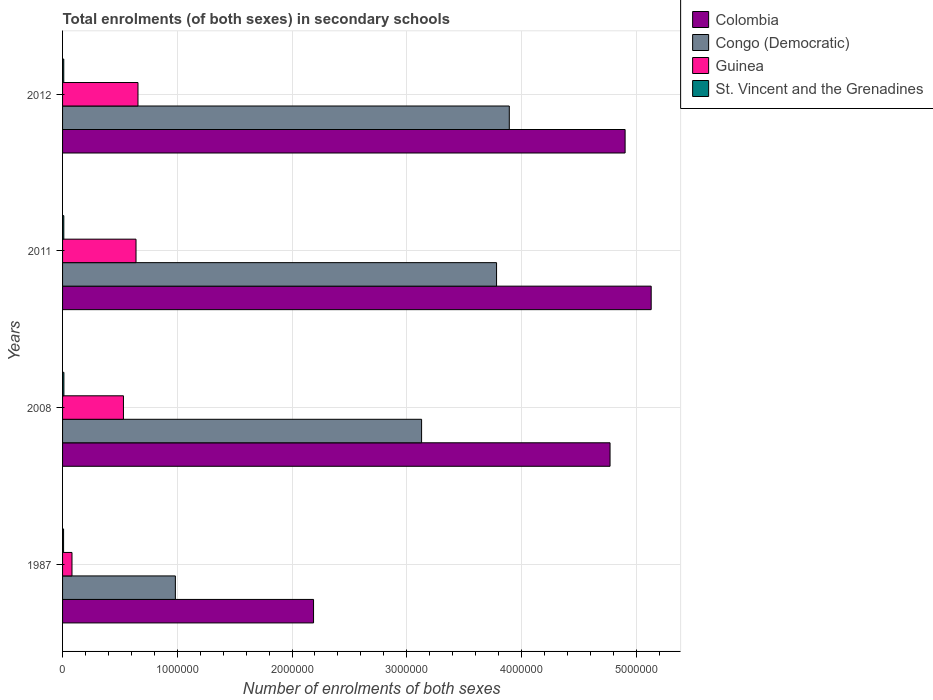How many groups of bars are there?
Provide a short and direct response. 4. Are the number of bars per tick equal to the number of legend labels?
Offer a terse response. Yes. How many bars are there on the 3rd tick from the top?
Your response must be concise. 4. How many bars are there on the 3rd tick from the bottom?
Provide a succinct answer. 4. What is the label of the 1st group of bars from the top?
Provide a short and direct response. 2012. What is the number of enrolments in secondary schools in Guinea in 2011?
Offer a very short reply. 6.40e+05. Across all years, what is the maximum number of enrolments in secondary schools in Congo (Democratic)?
Your answer should be very brief. 3.89e+06. Across all years, what is the minimum number of enrolments in secondary schools in Congo (Democratic)?
Give a very brief answer. 9.83e+05. In which year was the number of enrolments in secondary schools in Guinea maximum?
Provide a succinct answer. 2012. What is the total number of enrolments in secondary schools in Guinea in the graph?
Keep it short and to the point. 1.91e+06. What is the difference between the number of enrolments in secondary schools in St. Vincent and the Grenadines in 2008 and that in 2011?
Your response must be concise. 714. What is the difference between the number of enrolments in secondary schools in St. Vincent and the Grenadines in 1987 and the number of enrolments in secondary schools in Colombia in 2012?
Make the answer very short. -4.89e+06. What is the average number of enrolments in secondary schools in Congo (Democratic) per year?
Your response must be concise. 2.95e+06. In the year 2011, what is the difference between the number of enrolments in secondary schools in Colombia and number of enrolments in secondary schools in St. Vincent and the Grenadines?
Provide a short and direct response. 5.12e+06. What is the ratio of the number of enrolments in secondary schools in Congo (Democratic) in 2011 to that in 2012?
Keep it short and to the point. 0.97. What is the difference between the highest and the second highest number of enrolments in secondary schools in St. Vincent and the Grenadines?
Provide a short and direct response. 714. What is the difference between the highest and the lowest number of enrolments in secondary schools in Colombia?
Offer a terse response. 2.94e+06. Is the sum of the number of enrolments in secondary schools in St. Vincent and the Grenadines in 2011 and 2012 greater than the maximum number of enrolments in secondary schools in Guinea across all years?
Your answer should be compact. No. Is it the case that in every year, the sum of the number of enrolments in secondary schools in Colombia and number of enrolments in secondary schools in Guinea is greater than the sum of number of enrolments in secondary schools in St. Vincent and the Grenadines and number of enrolments in secondary schools in Congo (Democratic)?
Your answer should be compact. Yes. What does the 2nd bar from the top in 2012 represents?
Offer a terse response. Guinea. What does the 3rd bar from the bottom in 2012 represents?
Provide a short and direct response. Guinea. Is it the case that in every year, the sum of the number of enrolments in secondary schools in Congo (Democratic) and number of enrolments in secondary schools in Guinea is greater than the number of enrolments in secondary schools in St. Vincent and the Grenadines?
Your answer should be very brief. Yes. Are all the bars in the graph horizontal?
Give a very brief answer. Yes. How many years are there in the graph?
Make the answer very short. 4. What is the difference between two consecutive major ticks on the X-axis?
Keep it short and to the point. 1.00e+06. Are the values on the major ticks of X-axis written in scientific E-notation?
Offer a very short reply. No. Does the graph contain any zero values?
Your answer should be compact. No. Where does the legend appear in the graph?
Offer a terse response. Top right. How many legend labels are there?
Give a very brief answer. 4. What is the title of the graph?
Your answer should be compact. Total enrolments (of both sexes) in secondary schools. Does "Heavily indebted poor countries" appear as one of the legend labels in the graph?
Your answer should be compact. No. What is the label or title of the X-axis?
Give a very brief answer. Number of enrolments of both sexes. What is the Number of enrolments of both sexes of Colombia in 1987?
Your answer should be compact. 2.19e+06. What is the Number of enrolments of both sexes in Congo (Democratic) in 1987?
Your answer should be very brief. 9.83e+05. What is the Number of enrolments of both sexes in Guinea in 1987?
Provide a short and direct response. 8.21e+04. What is the Number of enrolments of both sexes of St. Vincent and the Grenadines in 1987?
Your answer should be very brief. 8785. What is the Number of enrolments of both sexes of Colombia in 2008?
Your response must be concise. 4.77e+06. What is the Number of enrolments of both sexes in Congo (Democratic) in 2008?
Make the answer very short. 3.13e+06. What is the Number of enrolments of both sexes in Guinea in 2008?
Your answer should be compact. 5.31e+05. What is the Number of enrolments of both sexes in St. Vincent and the Grenadines in 2008?
Provide a succinct answer. 1.16e+04. What is the Number of enrolments of both sexes of Colombia in 2011?
Keep it short and to the point. 5.13e+06. What is the Number of enrolments of both sexes of Congo (Democratic) in 2011?
Your answer should be very brief. 3.78e+06. What is the Number of enrolments of both sexes in Guinea in 2011?
Make the answer very short. 6.40e+05. What is the Number of enrolments of both sexes in St. Vincent and the Grenadines in 2011?
Provide a succinct answer. 1.09e+04. What is the Number of enrolments of both sexes in Colombia in 2012?
Offer a very short reply. 4.90e+06. What is the Number of enrolments of both sexes in Congo (Democratic) in 2012?
Offer a very short reply. 3.89e+06. What is the Number of enrolments of both sexes in Guinea in 2012?
Provide a succinct answer. 6.57e+05. What is the Number of enrolments of both sexes of St. Vincent and the Grenadines in 2012?
Give a very brief answer. 1.04e+04. Across all years, what is the maximum Number of enrolments of both sexes of Colombia?
Your answer should be very brief. 5.13e+06. Across all years, what is the maximum Number of enrolments of both sexes in Congo (Democratic)?
Your answer should be very brief. 3.89e+06. Across all years, what is the maximum Number of enrolments of both sexes in Guinea?
Provide a short and direct response. 6.57e+05. Across all years, what is the maximum Number of enrolments of both sexes in St. Vincent and the Grenadines?
Your answer should be very brief. 1.16e+04. Across all years, what is the minimum Number of enrolments of both sexes in Colombia?
Your answer should be very brief. 2.19e+06. Across all years, what is the minimum Number of enrolments of both sexes of Congo (Democratic)?
Provide a short and direct response. 9.83e+05. Across all years, what is the minimum Number of enrolments of both sexes of Guinea?
Offer a very short reply. 8.21e+04. Across all years, what is the minimum Number of enrolments of both sexes in St. Vincent and the Grenadines?
Keep it short and to the point. 8785. What is the total Number of enrolments of both sexes of Colombia in the graph?
Offer a terse response. 1.70e+07. What is the total Number of enrolments of both sexes in Congo (Democratic) in the graph?
Ensure brevity in your answer.  1.18e+07. What is the total Number of enrolments of both sexes of Guinea in the graph?
Make the answer very short. 1.91e+06. What is the total Number of enrolments of both sexes of St. Vincent and the Grenadines in the graph?
Keep it short and to the point. 4.18e+04. What is the difference between the Number of enrolments of both sexes of Colombia in 1987 and that in 2008?
Ensure brevity in your answer.  -2.58e+06. What is the difference between the Number of enrolments of both sexes of Congo (Democratic) in 1987 and that in 2008?
Provide a short and direct response. -2.15e+06. What is the difference between the Number of enrolments of both sexes of Guinea in 1987 and that in 2008?
Offer a very short reply. -4.49e+05. What is the difference between the Number of enrolments of both sexes of St. Vincent and the Grenadines in 1987 and that in 2008?
Provide a short and direct response. -2856. What is the difference between the Number of enrolments of both sexes of Colombia in 1987 and that in 2011?
Make the answer very short. -2.94e+06. What is the difference between the Number of enrolments of both sexes of Congo (Democratic) in 1987 and that in 2011?
Make the answer very short. -2.80e+06. What is the difference between the Number of enrolments of both sexes in Guinea in 1987 and that in 2011?
Ensure brevity in your answer.  -5.58e+05. What is the difference between the Number of enrolments of both sexes in St. Vincent and the Grenadines in 1987 and that in 2011?
Give a very brief answer. -2142. What is the difference between the Number of enrolments of both sexes of Colombia in 1987 and that in 2012?
Keep it short and to the point. -2.72e+06. What is the difference between the Number of enrolments of both sexes of Congo (Democratic) in 1987 and that in 2012?
Your answer should be compact. -2.91e+06. What is the difference between the Number of enrolments of both sexes of Guinea in 1987 and that in 2012?
Provide a short and direct response. -5.75e+05. What is the difference between the Number of enrolments of both sexes in St. Vincent and the Grenadines in 1987 and that in 2012?
Make the answer very short. -1634. What is the difference between the Number of enrolments of both sexes in Colombia in 2008 and that in 2011?
Provide a succinct answer. -3.59e+05. What is the difference between the Number of enrolments of both sexes of Congo (Democratic) in 2008 and that in 2011?
Offer a very short reply. -6.53e+05. What is the difference between the Number of enrolments of both sexes in Guinea in 2008 and that in 2011?
Provide a succinct answer. -1.10e+05. What is the difference between the Number of enrolments of both sexes in St. Vincent and the Grenadines in 2008 and that in 2011?
Offer a terse response. 714. What is the difference between the Number of enrolments of both sexes of Colombia in 2008 and that in 2012?
Ensure brevity in your answer.  -1.31e+05. What is the difference between the Number of enrolments of both sexes of Congo (Democratic) in 2008 and that in 2012?
Your answer should be very brief. -7.65e+05. What is the difference between the Number of enrolments of both sexes in Guinea in 2008 and that in 2012?
Your response must be concise. -1.27e+05. What is the difference between the Number of enrolments of both sexes of St. Vincent and the Grenadines in 2008 and that in 2012?
Your response must be concise. 1222. What is the difference between the Number of enrolments of both sexes in Colombia in 2011 and that in 2012?
Provide a succinct answer. 2.27e+05. What is the difference between the Number of enrolments of both sexes in Congo (Democratic) in 2011 and that in 2012?
Ensure brevity in your answer.  -1.11e+05. What is the difference between the Number of enrolments of both sexes in Guinea in 2011 and that in 2012?
Your answer should be compact. -1.71e+04. What is the difference between the Number of enrolments of both sexes of St. Vincent and the Grenadines in 2011 and that in 2012?
Provide a short and direct response. 508. What is the difference between the Number of enrolments of both sexes of Colombia in 1987 and the Number of enrolments of both sexes of Congo (Democratic) in 2008?
Provide a short and direct response. -9.42e+05. What is the difference between the Number of enrolments of both sexes in Colombia in 1987 and the Number of enrolments of both sexes in Guinea in 2008?
Offer a terse response. 1.66e+06. What is the difference between the Number of enrolments of both sexes of Colombia in 1987 and the Number of enrolments of both sexes of St. Vincent and the Grenadines in 2008?
Offer a terse response. 2.18e+06. What is the difference between the Number of enrolments of both sexes of Congo (Democratic) in 1987 and the Number of enrolments of both sexes of Guinea in 2008?
Provide a succinct answer. 4.53e+05. What is the difference between the Number of enrolments of both sexes of Congo (Democratic) in 1987 and the Number of enrolments of both sexes of St. Vincent and the Grenadines in 2008?
Keep it short and to the point. 9.72e+05. What is the difference between the Number of enrolments of both sexes of Guinea in 1987 and the Number of enrolments of both sexes of St. Vincent and the Grenadines in 2008?
Your response must be concise. 7.04e+04. What is the difference between the Number of enrolments of both sexes in Colombia in 1987 and the Number of enrolments of both sexes in Congo (Democratic) in 2011?
Ensure brevity in your answer.  -1.60e+06. What is the difference between the Number of enrolments of both sexes of Colombia in 1987 and the Number of enrolments of both sexes of Guinea in 2011?
Your answer should be compact. 1.55e+06. What is the difference between the Number of enrolments of both sexes in Colombia in 1987 and the Number of enrolments of both sexes in St. Vincent and the Grenadines in 2011?
Your answer should be very brief. 2.18e+06. What is the difference between the Number of enrolments of both sexes in Congo (Democratic) in 1987 and the Number of enrolments of both sexes in Guinea in 2011?
Your answer should be very brief. 3.43e+05. What is the difference between the Number of enrolments of both sexes in Congo (Democratic) in 1987 and the Number of enrolments of both sexes in St. Vincent and the Grenadines in 2011?
Give a very brief answer. 9.72e+05. What is the difference between the Number of enrolments of both sexes in Guinea in 1987 and the Number of enrolments of both sexes in St. Vincent and the Grenadines in 2011?
Offer a very short reply. 7.12e+04. What is the difference between the Number of enrolments of both sexes of Colombia in 1987 and the Number of enrolments of both sexes of Congo (Democratic) in 2012?
Provide a short and direct response. -1.71e+06. What is the difference between the Number of enrolments of both sexes of Colombia in 1987 and the Number of enrolments of both sexes of Guinea in 2012?
Provide a succinct answer. 1.53e+06. What is the difference between the Number of enrolments of both sexes in Colombia in 1987 and the Number of enrolments of both sexes in St. Vincent and the Grenadines in 2012?
Make the answer very short. 2.18e+06. What is the difference between the Number of enrolments of both sexes in Congo (Democratic) in 1987 and the Number of enrolments of both sexes in Guinea in 2012?
Offer a very short reply. 3.26e+05. What is the difference between the Number of enrolments of both sexes of Congo (Democratic) in 1987 and the Number of enrolments of both sexes of St. Vincent and the Grenadines in 2012?
Your answer should be very brief. 9.73e+05. What is the difference between the Number of enrolments of both sexes of Guinea in 1987 and the Number of enrolments of both sexes of St. Vincent and the Grenadines in 2012?
Offer a very short reply. 7.17e+04. What is the difference between the Number of enrolments of both sexes of Colombia in 2008 and the Number of enrolments of both sexes of Congo (Democratic) in 2011?
Offer a terse response. 9.89e+05. What is the difference between the Number of enrolments of both sexes of Colombia in 2008 and the Number of enrolments of both sexes of Guinea in 2011?
Keep it short and to the point. 4.13e+06. What is the difference between the Number of enrolments of both sexes in Colombia in 2008 and the Number of enrolments of both sexes in St. Vincent and the Grenadines in 2011?
Keep it short and to the point. 4.76e+06. What is the difference between the Number of enrolments of both sexes in Congo (Democratic) in 2008 and the Number of enrolments of both sexes in Guinea in 2011?
Ensure brevity in your answer.  2.49e+06. What is the difference between the Number of enrolments of both sexes of Congo (Democratic) in 2008 and the Number of enrolments of both sexes of St. Vincent and the Grenadines in 2011?
Make the answer very short. 3.12e+06. What is the difference between the Number of enrolments of both sexes of Guinea in 2008 and the Number of enrolments of both sexes of St. Vincent and the Grenadines in 2011?
Your response must be concise. 5.20e+05. What is the difference between the Number of enrolments of both sexes in Colombia in 2008 and the Number of enrolments of both sexes in Congo (Democratic) in 2012?
Give a very brief answer. 8.78e+05. What is the difference between the Number of enrolments of both sexes in Colombia in 2008 and the Number of enrolments of both sexes in Guinea in 2012?
Your answer should be very brief. 4.11e+06. What is the difference between the Number of enrolments of both sexes in Colombia in 2008 and the Number of enrolments of both sexes in St. Vincent and the Grenadines in 2012?
Your answer should be compact. 4.76e+06. What is the difference between the Number of enrolments of both sexes of Congo (Democratic) in 2008 and the Number of enrolments of both sexes of Guinea in 2012?
Your answer should be compact. 2.47e+06. What is the difference between the Number of enrolments of both sexes of Congo (Democratic) in 2008 and the Number of enrolments of both sexes of St. Vincent and the Grenadines in 2012?
Give a very brief answer. 3.12e+06. What is the difference between the Number of enrolments of both sexes in Guinea in 2008 and the Number of enrolments of both sexes in St. Vincent and the Grenadines in 2012?
Your answer should be compact. 5.20e+05. What is the difference between the Number of enrolments of both sexes in Colombia in 2011 and the Number of enrolments of both sexes in Congo (Democratic) in 2012?
Your answer should be very brief. 1.24e+06. What is the difference between the Number of enrolments of both sexes in Colombia in 2011 and the Number of enrolments of both sexes in Guinea in 2012?
Make the answer very short. 4.47e+06. What is the difference between the Number of enrolments of both sexes of Colombia in 2011 and the Number of enrolments of both sexes of St. Vincent and the Grenadines in 2012?
Make the answer very short. 5.12e+06. What is the difference between the Number of enrolments of both sexes of Congo (Democratic) in 2011 and the Number of enrolments of both sexes of Guinea in 2012?
Give a very brief answer. 3.13e+06. What is the difference between the Number of enrolments of both sexes in Congo (Democratic) in 2011 and the Number of enrolments of both sexes in St. Vincent and the Grenadines in 2012?
Your response must be concise. 3.77e+06. What is the difference between the Number of enrolments of both sexes of Guinea in 2011 and the Number of enrolments of both sexes of St. Vincent and the Grenadines in 2012?
Your answer should be compact. 6.30e+05. What is the average Number of enrolments of both sexes in Colombia per year?
Offer a very short reply. 4.25e+06. What is the average Number of enrolments of both sexes of Congo (Democratic) per year?
Your answer should be compact. 2.95e+06. What is the average Number of enrolments of both sexes in Guinea per year?
Provide a succinct answer. 4.78e+05. What is the average Number of enrolments of both sexes of St. Vincent and the Grenadines per year?
Your answer should be very brief. 1.04e+04. In the year 1987, what is the difference between the Number of enrolments of both sexes in Colombia and Number of enrolments of both sexes in Congo (Democratic)?
Offer a terse response. 1.20e+06. In the year 1987, what is the difference between the Number of enrolments of both sexes of Colombia and Number of enrolments of both sexes of Guinea?
Offer a very short reply. 2.11e+06. In the year 1987, what is the difference between the Number of enrolments of both sexes in Colombia and Number of enrolments of both sexes in St. Vincent and the Grenadines?
Keep it short and to the point. 2.18e+06. In the year 1987, what is the difference between the Number of enrolments of both sexes in Congo (Democratic) and Number of enrolments of both sexes in Guinea?
Make the answer very short. 9.01e+05. In the year 1987, what is the difference between the Number of enrolments of both sexes in Congo (Democratic) and Number of enrolments of both sexes in St. Vincent and the Grenadines?
Offer a terse response. 9.75e+05. In the year 1987, what is the difference between the Number of enrolments of both sexes in Guinea and Number of enrolments of both sexes in St. Vincent and the Grenadines?
Keep it short and to the point. 7.33e+04. In the year 2008, what is the difference between the Number of enrolments of both sexes of Colombia and Number of enrolments of both sexes of Congo (Democratic)?
Your answer should be compact. 1.64e+06. In the year 2008, what is the difference between the Number of enrolments of both sexes of Colombia and Number of enrolments of both sexes of Guinea?
Give a very brief answer. 4.24e+06. In the year 2008, what is the difference between the Number of enrolments of both sexes of Colombia and Number of enrolments of both sexes of St. Vincent and the Grenadines?
Keep it short and to the point. 4.76e+06. In the year 2008, what is the difference between the Number of enrolments of both sexes in Congo (Democratic) and Number of enrolments of both sexes in Guinea?
Provide a succinct answer. 2.60e+06. In the year 2008, what is the difference between the Number of enrolments of both sexes in Congo (Democratic) and Number of enrolments of both sexes in St. Vincent and the Grenadines?
Make the answer very short. 3.12e+06. In the year 2008, what is the difference between the Number of enrolments of both sexes in Guinea and Number of enrolments of both sexes in St. Vincent and the Grenadines?
Provide a succinct answer. 5.19e+05. In the year 2011, what is the difference between the Number of enrolments of both sexes of Colombia and Number of enrolments of both sexes of Congo (Democratic)?
Your response must be concise. 1.35e+06. In the year 2011, what is the difference between the Number of enrolments of both sexes in Colombia and Number of enrolments of both sexes in Guinea?
Offer a very short reply. 4.49e+06. In the year 2011, what is the difference between the Number of enrolments of both sexes in Colombia and Number of enrolments of both sexes in St. Vincent and the Grenadines?
Offer a terse response. 5.12e+06. In the year 2011, what is the difference between the Number of enrolments of both sexes of Congo (Democratic) and Number of enrolments of both sexes of Guinea?
Offer a terse response. 3.14e+06. In the year 2011, what is the difference between the Number of enrolments of both sexes in Congo (Democratic) and Number of enrolments of both sexes in St. Vincent and the Grenadines?
Provide a short and direct response. 3.77e+06. In the year 2011, what is the difference between the Number of enrolments of both sexes of Guinea and Number of enrolments of both sexes of St. Vincent and the Grenadines?
Your response must be concise. 6.29e+05. In the year 2012, what is the difference between the Number of enrolments of both sexes in Colombia and Number of enrolments of both sexes in Congo (Democratic)?
Provide a short and direct response. 1.01e+06. In the year 2012, what is the difference between the Number of enrolments of both sexes in Colombia and Number of enrolments of both sexes in Guinea?
Your response must be concise. 4.25e+06. In the year 2012, what is the difference between the Number of enrolments of both sexes in Colombia and Number of enrolments of both sexes in St. Vincent and the Grenadines?
Offer a terse response. 4.89e+06. In the year 2012, what is the difference between the Number of enrolments of both sexes of Congo (Democratic) and Number of enrolments of both sexes of Guinea?
Provide a succinct answer. 3.24e+06. In the year 2012, what is the difference between the Number of enrolments of both sexes of Congo (Democratic) and Number of enrolments of both sexes of St. Vincent and the Grenadines?
Your answer should be very brief. 3.88e+06. In the year 2012, what is the difference between the Number of enrolments of both sexes in Guinea and Number of enrolments of both sexes in St. Vincent and the Grenadines?
Offer a terse response. 6.47e+05. What is the ratio of the Number of enrolments of both sexes of Colombia in 1987 to that in 2008?
Provide a short and direct response. 0.46. What is the ratio of the Number of enrolments of both sexes of Congo (Democratic) in 1987 to that in 2008?
Provide a short and direct response. 0.31. What is the ratio of the Number of enrolments of both sexes in Guinea in 1987 to that in 2008?
Provide a short and direct response. 0.15. What is the ratio of the Number of enrolments of both sexes of St. Vincent and the Grenadines in 1987 to that in 2008?
Your answer should be very brief. 0.75. What is the ratio of the Number of enrolments of both sexes in Colombia in 1987 to that in 2011?
Your answer should be very brief. 0.43. What is the ratio of the Number of enrolments of both sexes of Congo (Democratic) in 1987 to that in 2011?
Give a very brief answer. 0.26. What is the ratio of the Number of enrolments of both sexes of Guinea in 1987 to that in 2011?
Give a very brief answer. 0.13. What is the ratio of the Number of enrolments of both sexes in St. Vincent and the Grenadines in 1987 to that in 2011?
Make the answer very short. 0.8. What is the ratio of the Number of enrolments of both sexes of Colombia in 1987 to that in 2012?
Provide a short and direct response. 0.45. What is the ratio of the Number of enrolments of both sexes of Congo (Democratic) in 1987 to that in 2012?
Make the answer very short. 0.25. What is the ratio of the Number of enrolments of both sexes of Guinea in 1987 to that in 2012?
Provide a short and direct response. 0.12. What is the ratio of the Number of enrolments of both sexes in St. Vincent and the Grenadines in 1987 to that in 2012?
Offer a terse response. 0.84. What is the ratio of the Number of enrolments of both sexes in Colombia in 2008 to that in 2011?
Offer a terse response. 0.93. What is the ratio of the Number of enrolments of both sexes of Congo (Democratic) in 2008 to that in 2011?
Your answer should be very brief. 0.83. What is the ratio of the Number of enrolments of both sexes in Guinea in 2008 to that in 2011?
Offer a very short reply. 0.83. What is the ratio of the Number of enrolments of both sexes of St. Vincent and the Grenadines in 2008 to that in 2011?
Offer a very short reply. 1.07. What is the ratio of the Number of enrolments of both sexes in Colombia in 2008 to that in 2012?
Your answer should be compact. 0.97. What is the ratio of the Number of enrolments of both sexes in Congo (Democratic) in 2008 to that in 2012?
Your response must be concise. 0.8. What is the ratio of the Number of enrolments of both sexes in Guinea in 2008 to that in 2012?
Your answer should be very brief. 0.81. What is the ratio of the Number of enrolments of both sexes of St. Vincent and the Grenadines in 2008 to that in 2012?
Your answer should be very brief. 1.12. What is the ratio of the Number of enrolments of both sexes in Colombia in 2011 to that in 2012?
Your answer should be compact. 1.05. What is the ratio of the Number of enrolments of both sexes of Congo (Democratic) in 2011 to that in 2012?
Keep it short and to the point. 0.97. What is the ratio of the Number of enrolments of both sexes of Guinea in 2011 to that in 2012?
Offer a very short reply. 0.97. What is the ratio of the Number of enrolments of both sexes in St. Vincent and the Grenadines in 2011 to that in 2012?
Offer a very short reply. 1.05. What is the difference between the highest and the second highest Number of enrolments of both sexes in Colombia?
Keep it short and to the point. 2.27e+05. What is the difference between the highest and the second highest Number of enrolments of both sexes of Congo (Democratic)?
Provide a succinct answer. 1.11e+05. What is the difference between the highest and the second highest Number of enrolments of both sexes of Guinea?
Ensure brevity in your answer.  1.71e+04. What is the difference between the highest and the second highest Number of enrolments of both sexes in St. Vincent and the Grenadines?
Provide a succinct answer. 714. What is the difference between the highest and the lowest Number of enrolments of both sexes in Colombia?
Your answer should be very brief. 2.94e+06. What is the difference between the highest and the lowest Number of enrolments of both sexes in Congo (Democratic)?
Give a very brief answer. 2.91e+06. What is the difference between the highest and the lowest Number of enrolments of both sexes of Guinea?
Keep it short and to the point. 5.75e+05. What is the difference between the highest and the lowest Number of enrolments of both sexes in St. Vincent and the Grenadines?
Give a very brief answer. 2856. 